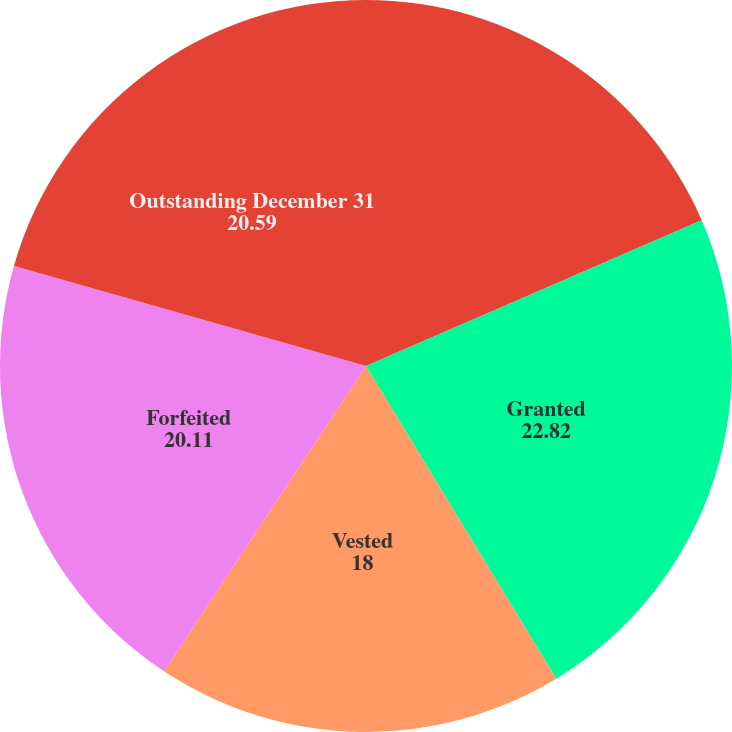Convert chart to OTSL. <chart><loc_0><loc_0><loc_500><loc_500><pie_chart><fcel>Outstanding January 1<fcel>Granted<fcel>Vested<fcel>Forfeited<fcel>Outstanding December 31<nl><fcel>18.48%<fcel>22.82%<fcel>18.0%<fcel>20.11%<fcel>20.59%<nl></chart> 